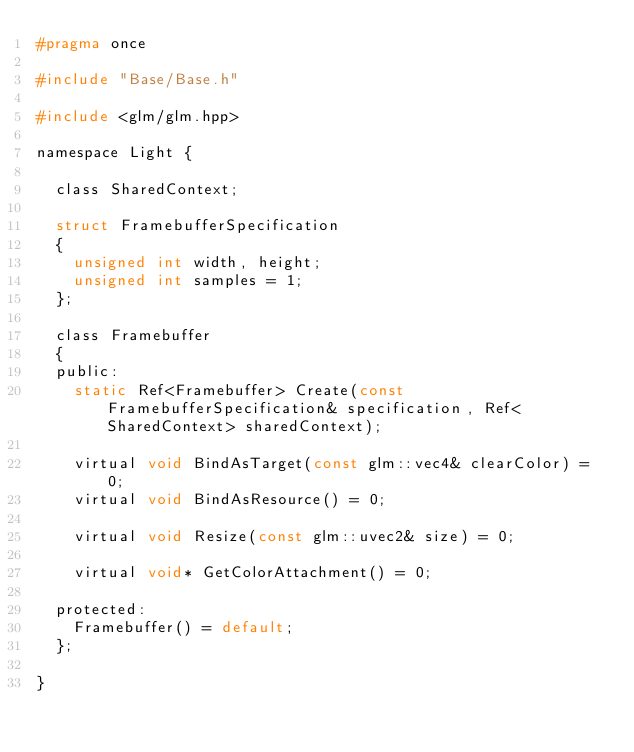Convert code to text. <code><loc_0><loc_0><loc_500><loc_500><_C_>#pragma once

#include "Base/Base.h"

#include <glm/glm.hpp>

namespace Light {

	class SharedContext;

	struct FramebufferSpecification
	{
		unsigned int width, height;
		unsigned int samples = 1;
	};

	class Framebuffer
	{
	public:
		static Ref<Framebuffer> Create(const FramebufferSpecification& specification, Ref<SharedContext> sharedContext);

		virtual void BindAsTarget(const glm::vec4& clearColor) = 0;
		virtual void BindAsResource() = 0;

		virtual void Resize(const glm::uvec2& size) = 0;

		virtual void* GetColorAttachment() = 0;

	protected:
		Framebuffer() = default;
	};

}</code> 